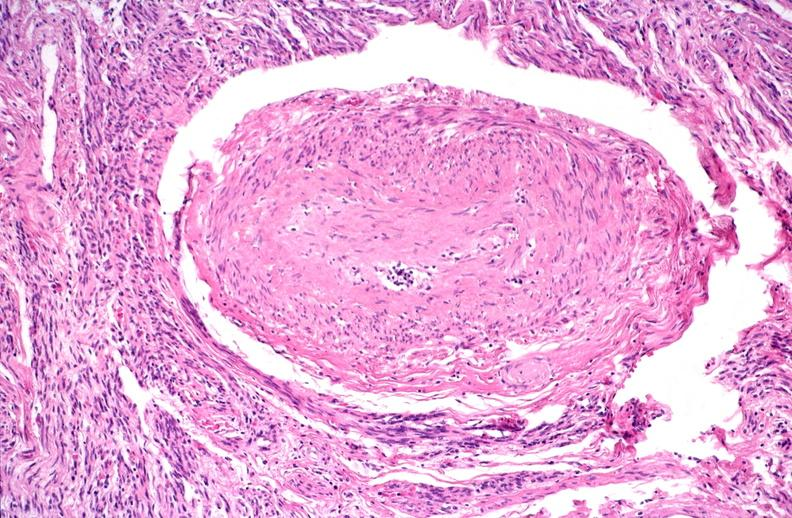does close-up of lesion show kidney, polyarteritis nodosa?
Answer the question using a single word or phrase. No 